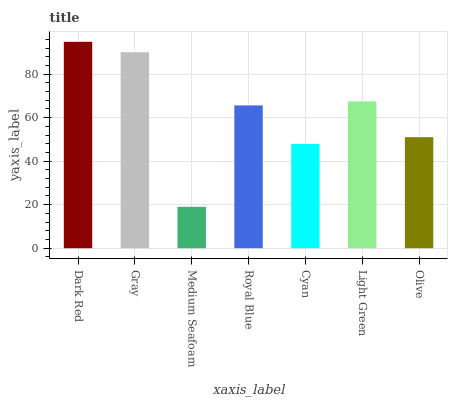Is Gray the minimum?
Answer yes or no. No. Is Gray the maximum?
Answer yes or no. No. Is Dark Red greater than Gray?
Answer yes or no. Yes. Is Gray less than Dark Red?
Answer yes or no. Yes. Is Gray greater than Dark Red?
Answer yes or no. No. Is Dark Red less than Gray?
Answer yes or no. No. Is Royal Blue the high median?
Answer yes or no. Yes. Is Royal Blue the low median?
Answer yes or no. Yes. Is Gray the high median?
Answer yes or no. No. Is Gray the low median?
Answer yes or no. No. 